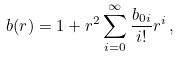Convert formula to latex. <formula><loc_0><loc_0><loc_500><loc_500>b ( r ) = 1 + r ^ { 2 } \sum _ { i = 0 } ^ { \infty } \frac { b _ { 0 i } } { i ! } r ^ { i } \, ,</formula> 